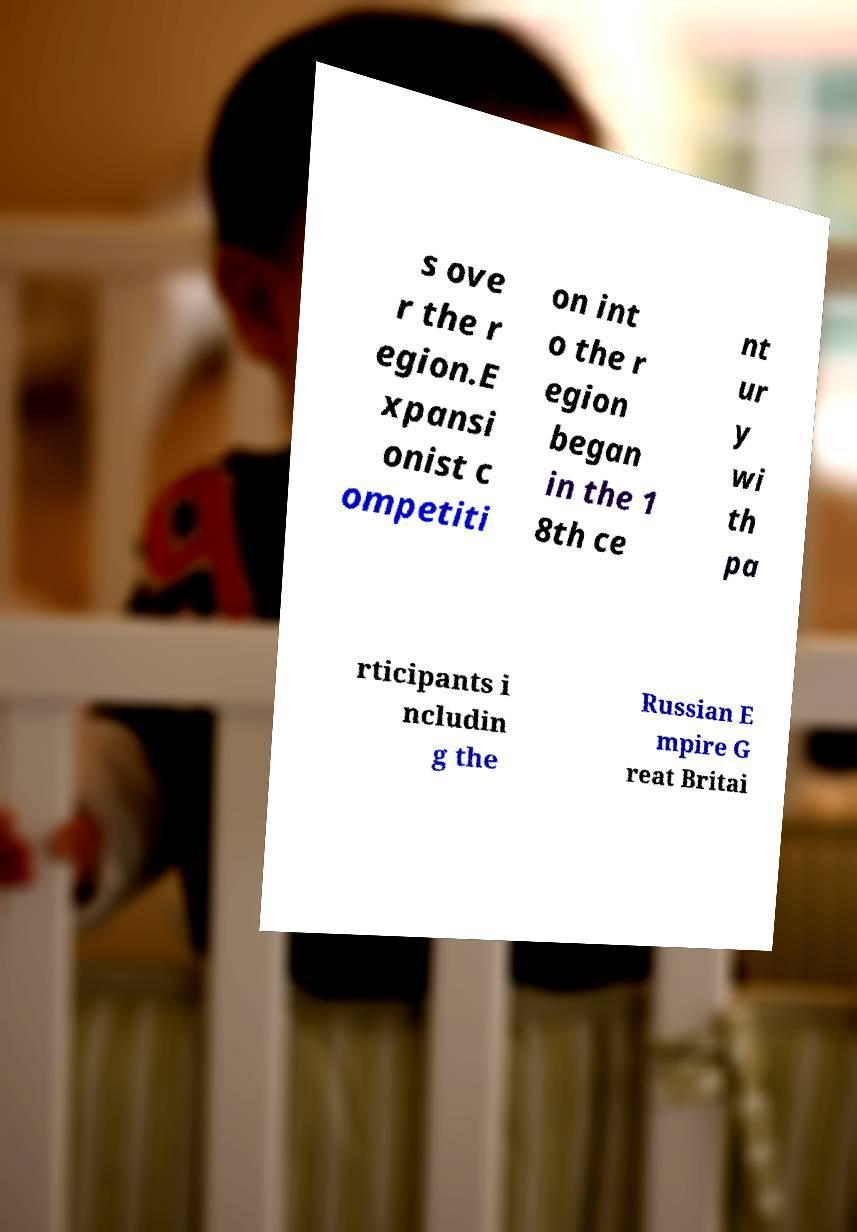What messages or text are displayed in this image? I need them in a readable, typed format. s ove r the r egion.E xpansi onist c ompetiti on int o the r egion began in the 1 8th ce nt ur y wi th pa rticipants i ncludin g the Russian E mpire G reat Britai 